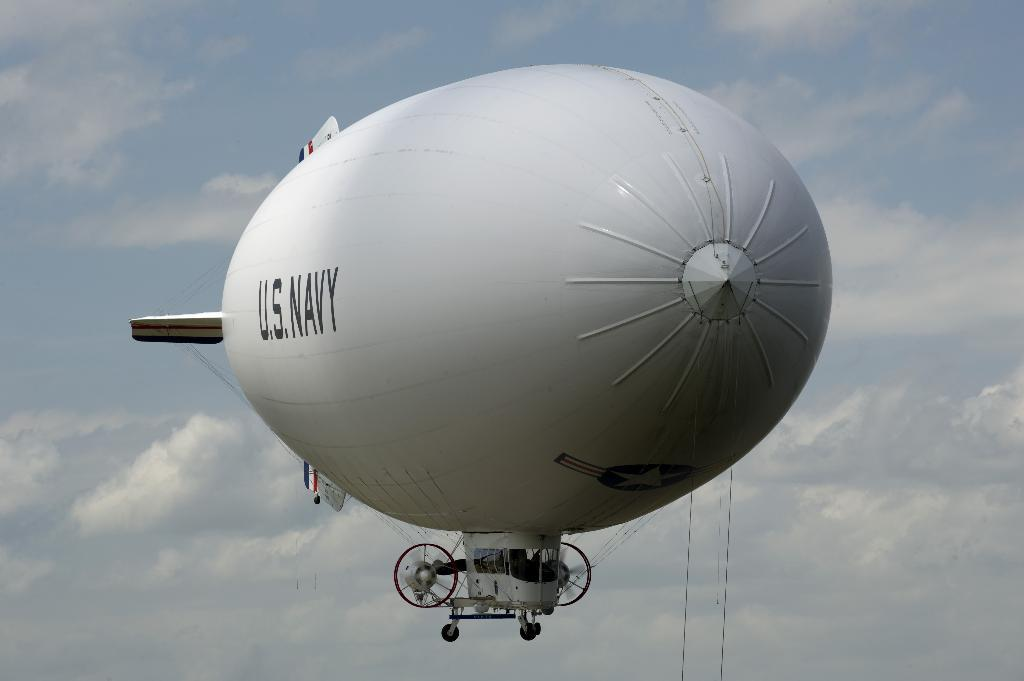<image>
Describe the image concisely. a white blimp advertising the US navy in a clear blue sky 